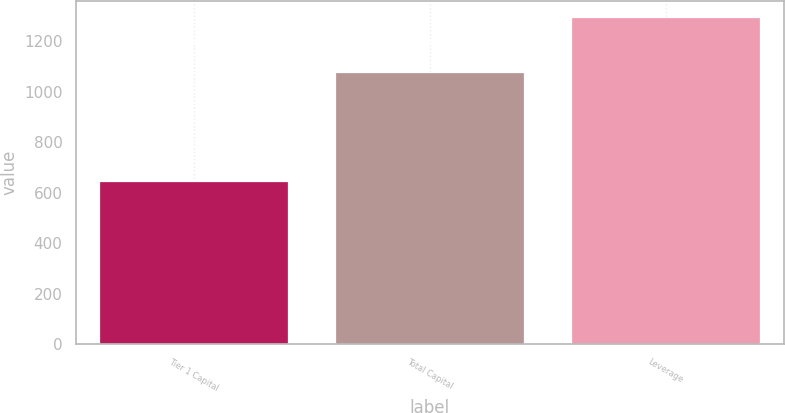<chart> <loc_0><loc_0><loc_500><loc_500><bar_chart><fcel>Tier 1 Capital<fcel>Total Capital<fcel>Leverage<nl><fcel>647<fcel>1079<fcel>1296<nl></chart> 